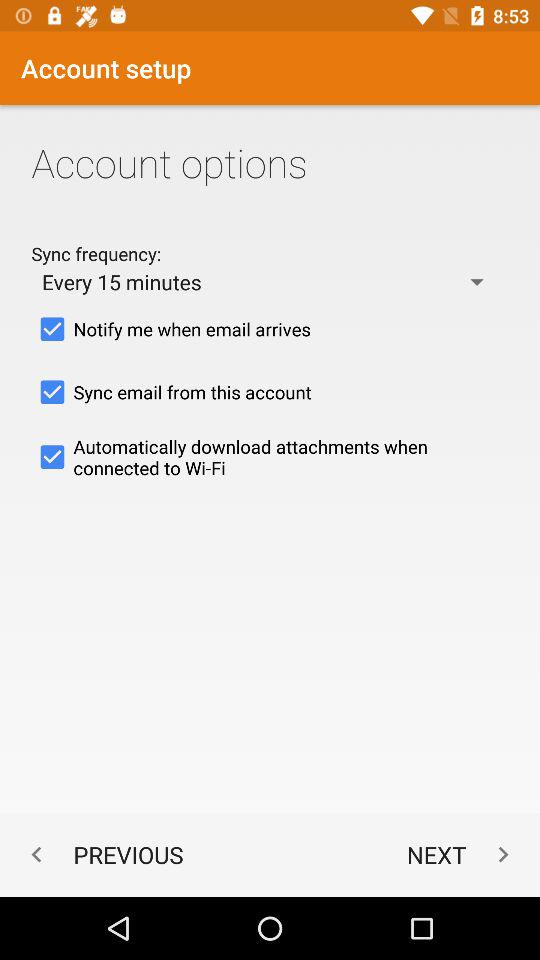Up to how big can downloaded attachments be?
When the provided information is insufficient, respond with <no answer>. <no answer> 